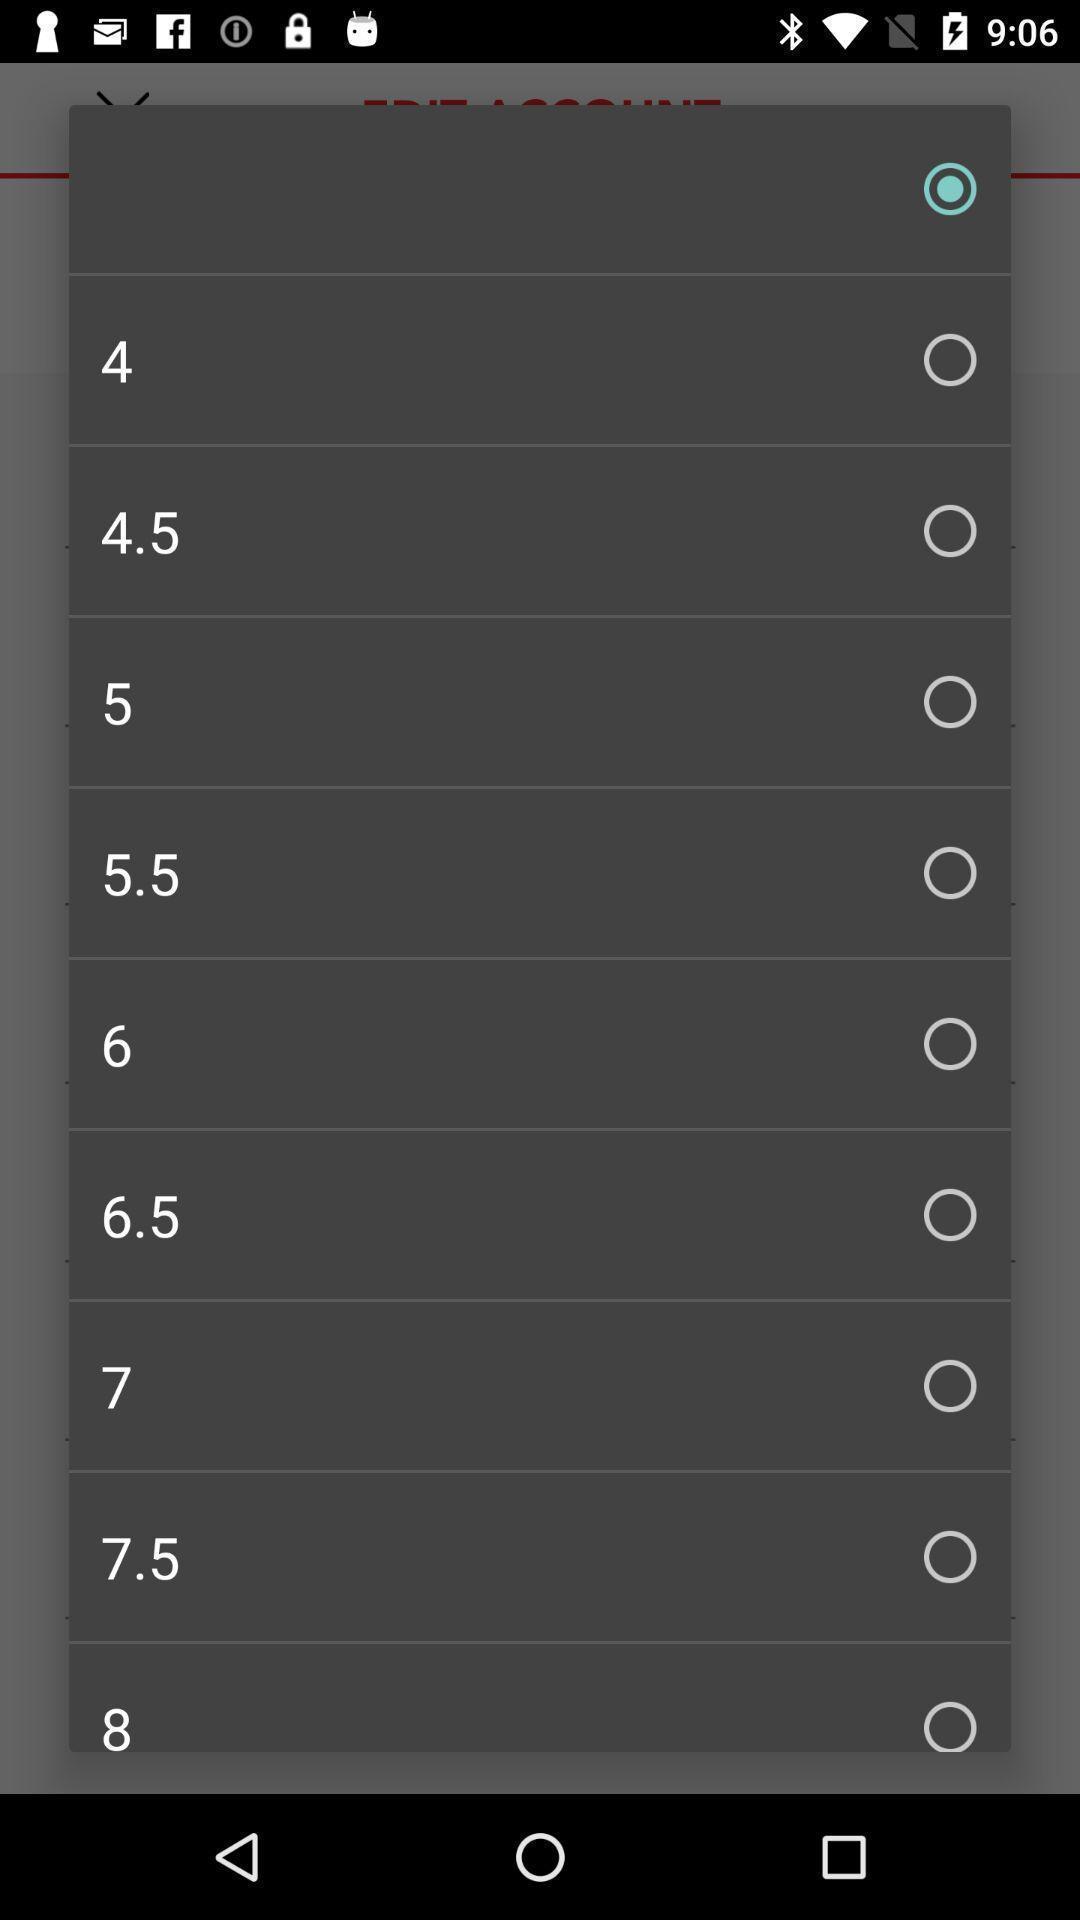Explain what's happening in this screen capture. Sizes page of an online footwear app. 